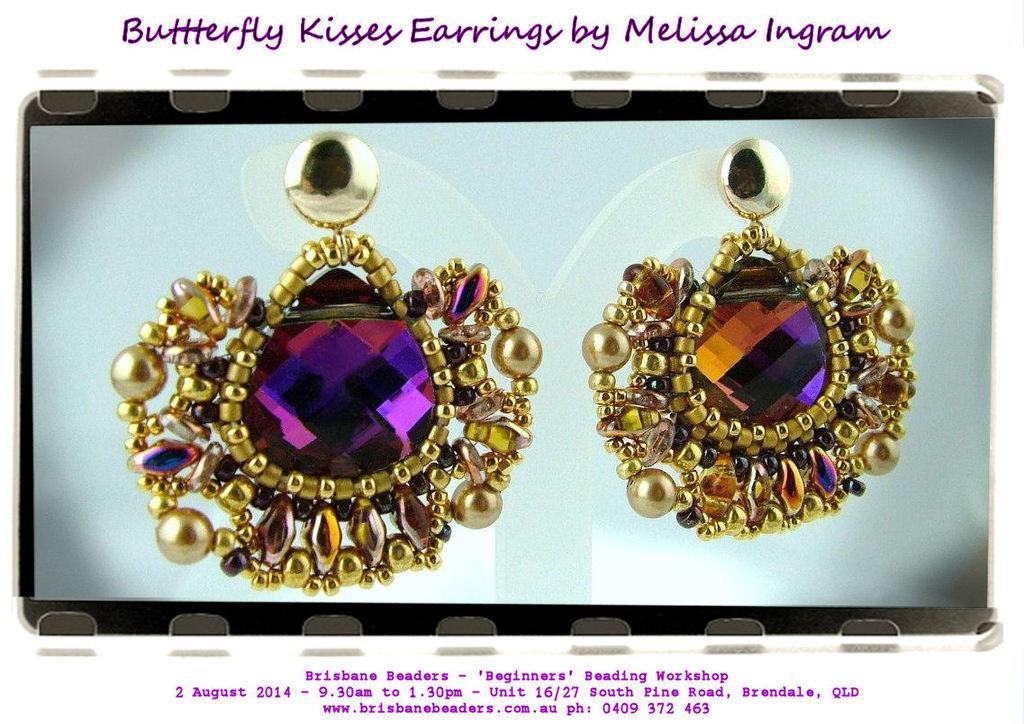What kind of jewelry is this?
Offer a terse response. Earrings. 